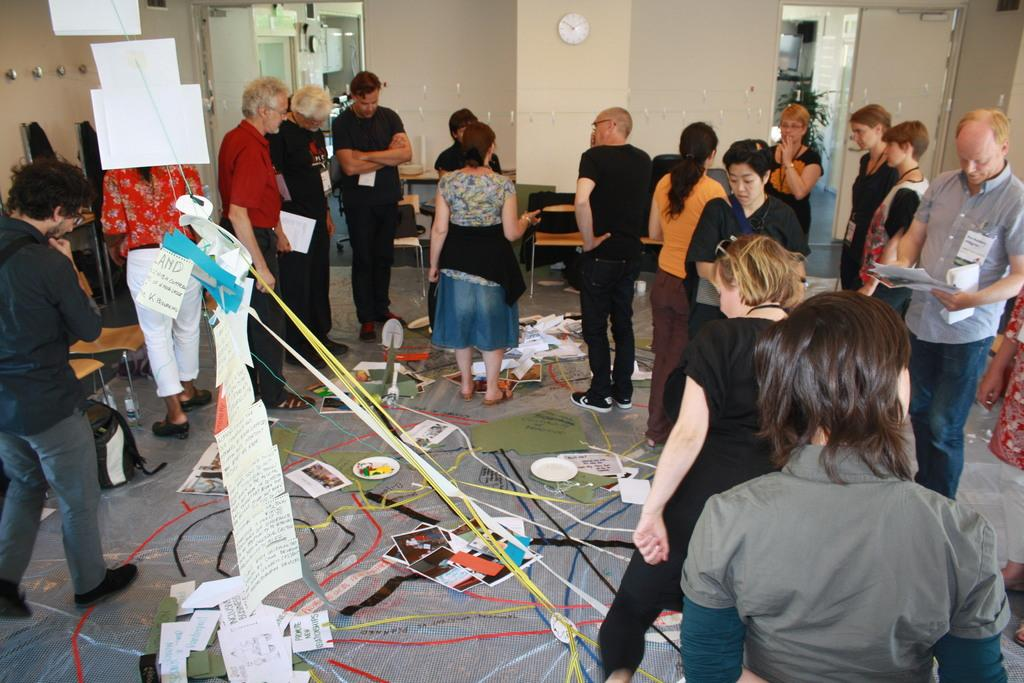What is happening in the image? There are people standing in the image. What objects can be seen in the hands of the people? Papers are visible in the image. What type of infrastructure can be seen in the image? Cables are visible in the image. What is present in the background of the image? There is a wall in the background of the image. What is hanging on the wall in the background? There is a clock on the wall in the background. What type of cows can be seen grazing in the background of the image? There are no cows present in the image; it features people standing, papers, cables, a wall, and a clock on the wall. What month is it in the image? The month cannot be determined from the image, as there is no information about the time or date. 